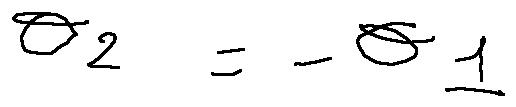Convert formula to latex. <formula><loc_0><loc_0><loc_500><loc_500>\theta _ { 2 } = - \theta _ { 1 }</formula> 